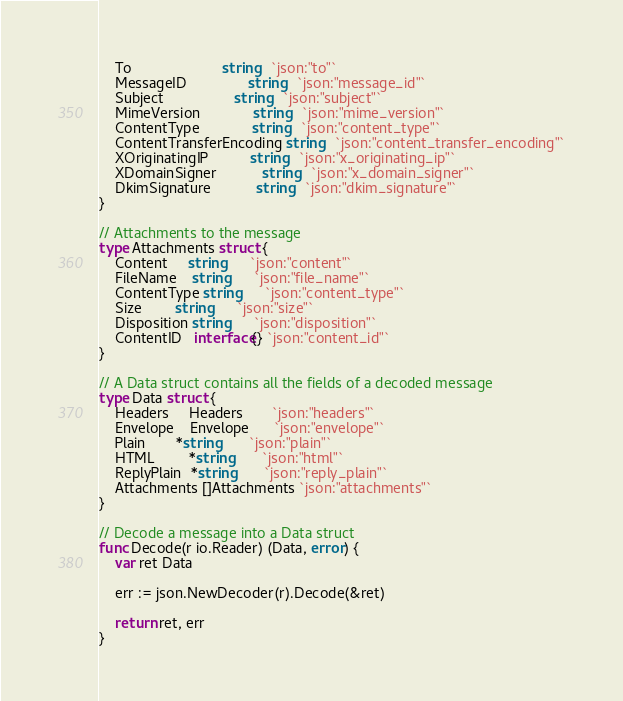<code> <loc_0><loc_0><loc_500><loc_500><_Go_>	To                      string   `json:"to"`
	MessageID               string   `json:"message_id"`
	Subject                 string   `json:"subject"`
	MimeVersion             string   `json:"mime_version"`
	ContentType             string   `json:"content_type"`
	ContentTransferEncoding string   `json:"content_transfer_encoding"`
	XOriginatingIP          string   `json:"x_originating_ip"`
	XDomainSigner           string   `json:"x_domain_signer"`
	DkimSignature           string   `json:"dkim_signature"`
}

// Attachments to the message
type Attachments struct {
	Content     string      `json:"content"`
	FileName    string      `json:"file_name"`
	ContentType string      `json:"content_type"`
	Size        string      `json:"size"`
	Disposition string      `json:"disposition"`
	ContentID   interface{} `json:"content_id"`
}

// A Data struct contains all the fields of a decoded message
type Data struct {
	Headers     Headers       `json:"headers"`
	Envelope    Envelope      `json:"envelope"`
	Plain       *string       `json:"plain"`
	HTML        *string       `json:"html"`
	ReplyPlain  *string       `json:"reply_plain"`
	Attachments []Attachments `json:"attachments"`
}

// Decode a message into a Data struct
func Decode(r io.Reader) (Data, error) {
	var ret Data

	err := json.NewDecoder(r).Decode(&ret)

	return ret, err
}
</code> 